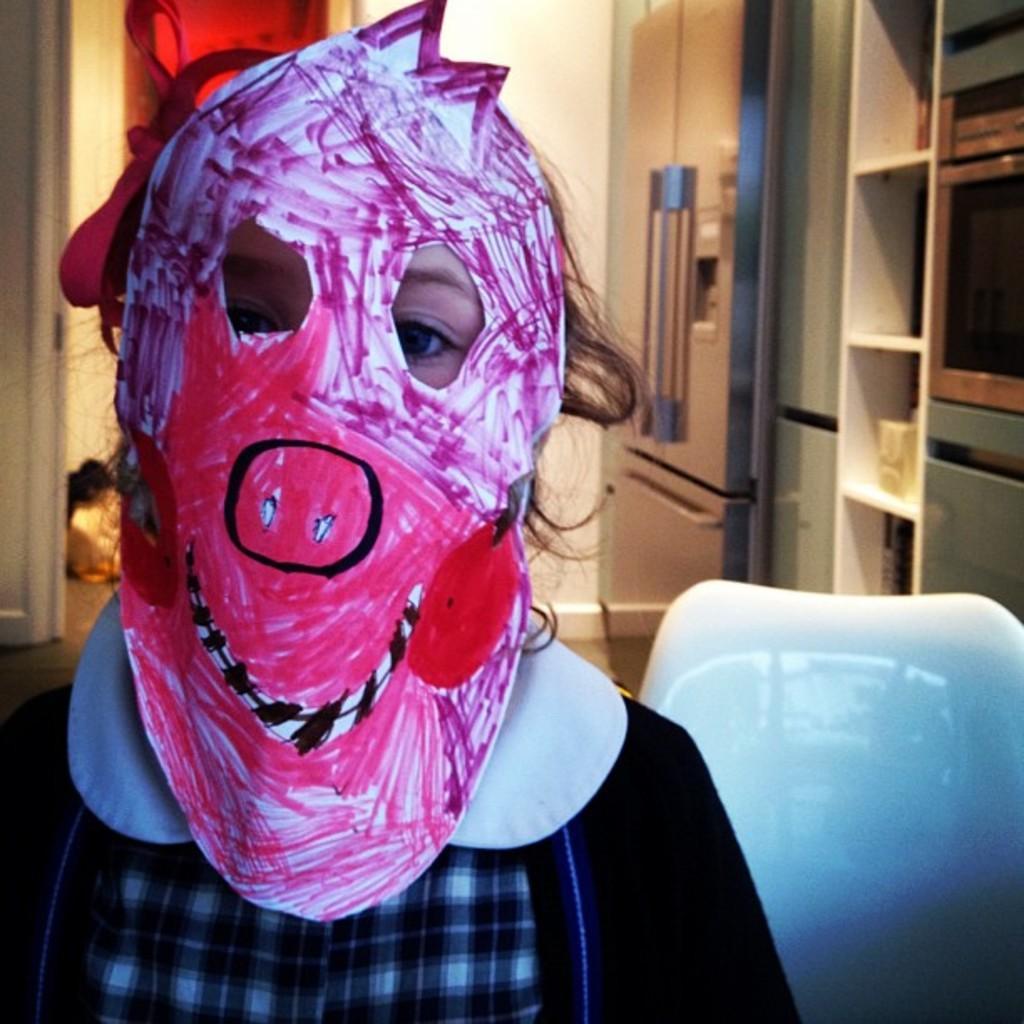How would you summarize this image in a sentence or two? In the image we can see a person wearing clothes and a face mask. This is a chair, refrigerator, shelf, floor and a wall. 